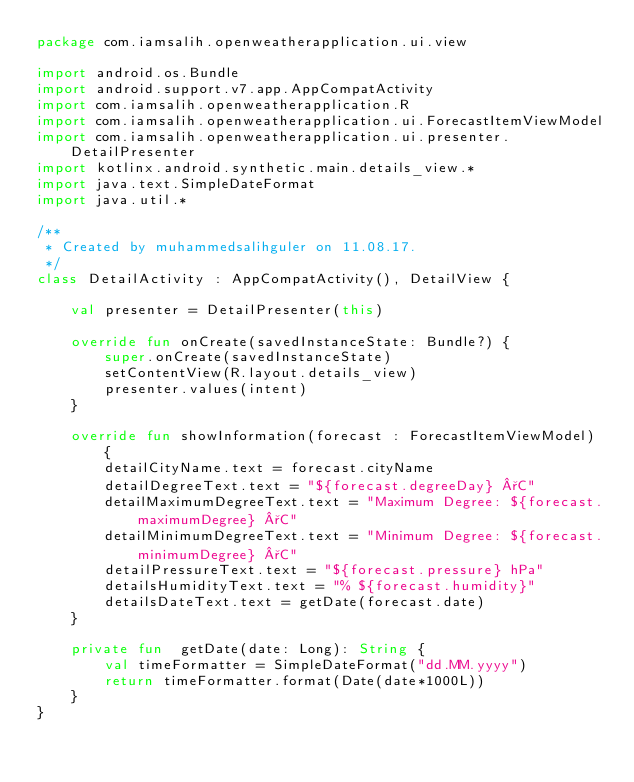<code> <loc_0><loc_0><loc_500><loc_500><_Kotlin_>package com.iamsalih.openweatherapplication.ui.view

import android.os.Bundle
import android.support.v7.app.AppCompatActivity
import com.iamsalih.openweatherapplication.R
import com.iamsalih.openweatherapplication.ui.ForecastItemViewModel
import com.iamsalih.openweatherapplication.ui.presenter.DetailPresenter
import kotlinx.android.synthetic.main.details_view.*
import java.text.SimpleDateFormat
import java.util.*

/**
 * Created by muhammedsalihguler on 11.08.17.
 */
class DetailActivity : AppCompatActivity(), DetailView {

    val presenter = DetailPresenter(this)

    override fun onCreate(savedInstanceState: Bundle?) {
        super.onCreate(savedInstanceState)
        setContentView(R.layout.details_view)
        presenter.values(intent)
    }

    override fun showInformation(forecast : ForecastItemViewModel) {
        detailCityName.text = forecast.cityName
        detailDegreeText.text = "${forecast.degreeDay} °C"
        detailMaximumDegreeText.text = "Maximum Degree: ${forecast.maximumDegree} °C"
        detailMinimumDegreeText.text = "Minimum Degree: ${forecast.minimumDegree} °C"
        detailPressureText.text = "${forecast.pressure} hPa"
        detailsHumidityText.text = "% ${forecast.humidity}"
        detailsDateText.text = getDate(forecast.date)
    }

    private fun  getDate(date: Long): String {
        val timeFormatter = SimpleDateFormat("dd.MM.yyyy")
        return timeFormatter.format(Date(date*1000L))
    }
}</code> 